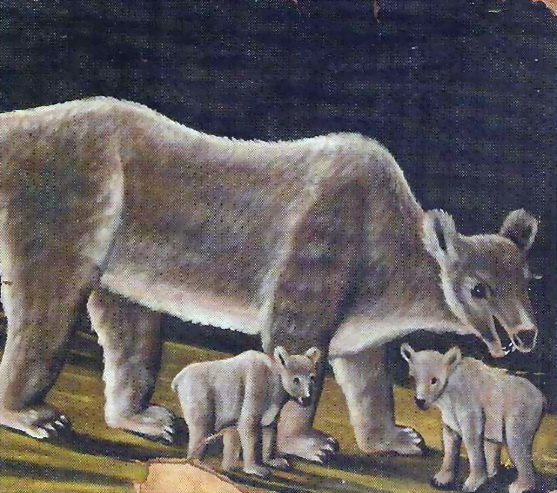What do the expressions of the bears suggest about their emotions? The mother bear's expression, with a slightly open mouth and attentive eyes, suggests watchfulness and care. She seems to be keeping a close eye on her environment, ready to protect her cubs from any potential threat. The cubs, however, appear more relaxed and curious. Their playful stance and innocent expressions convey a sense of exploration and wonder, typical of young animals discovering the world around them. Tell me a very long and detailed description about the surroundings and the moment captured in the image. The image captures a serene moment in the wild, where a mother bear and her cubs find a brief respite. The mother bear's fur, thick and rugged, blends seamlessly with the moss-covered forest floor below her. The cubs, with their lighter fur, stand out against the dark, textured background. The forest itself is dense, with towering trees whose leaves form a green canopy overhead. Sunlight filters through the leaves, casting dappled shadows that dance on the forest floor. In the distance, a faint glimmer of a stream can be seen, its water reflecting the sky above. The air is thick with the scent of pine and earth, and the only sounds are the gentle rustling of leaves and the occasional call of a bird. This scene is a testament to the timeless bond between a mother and her young, set against the backdrop of an untouched, ancient forest. 